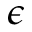Convert formula to latex. <formula><loc_0><loc_0><loc_500><loc_500>\epsilon</formula> 